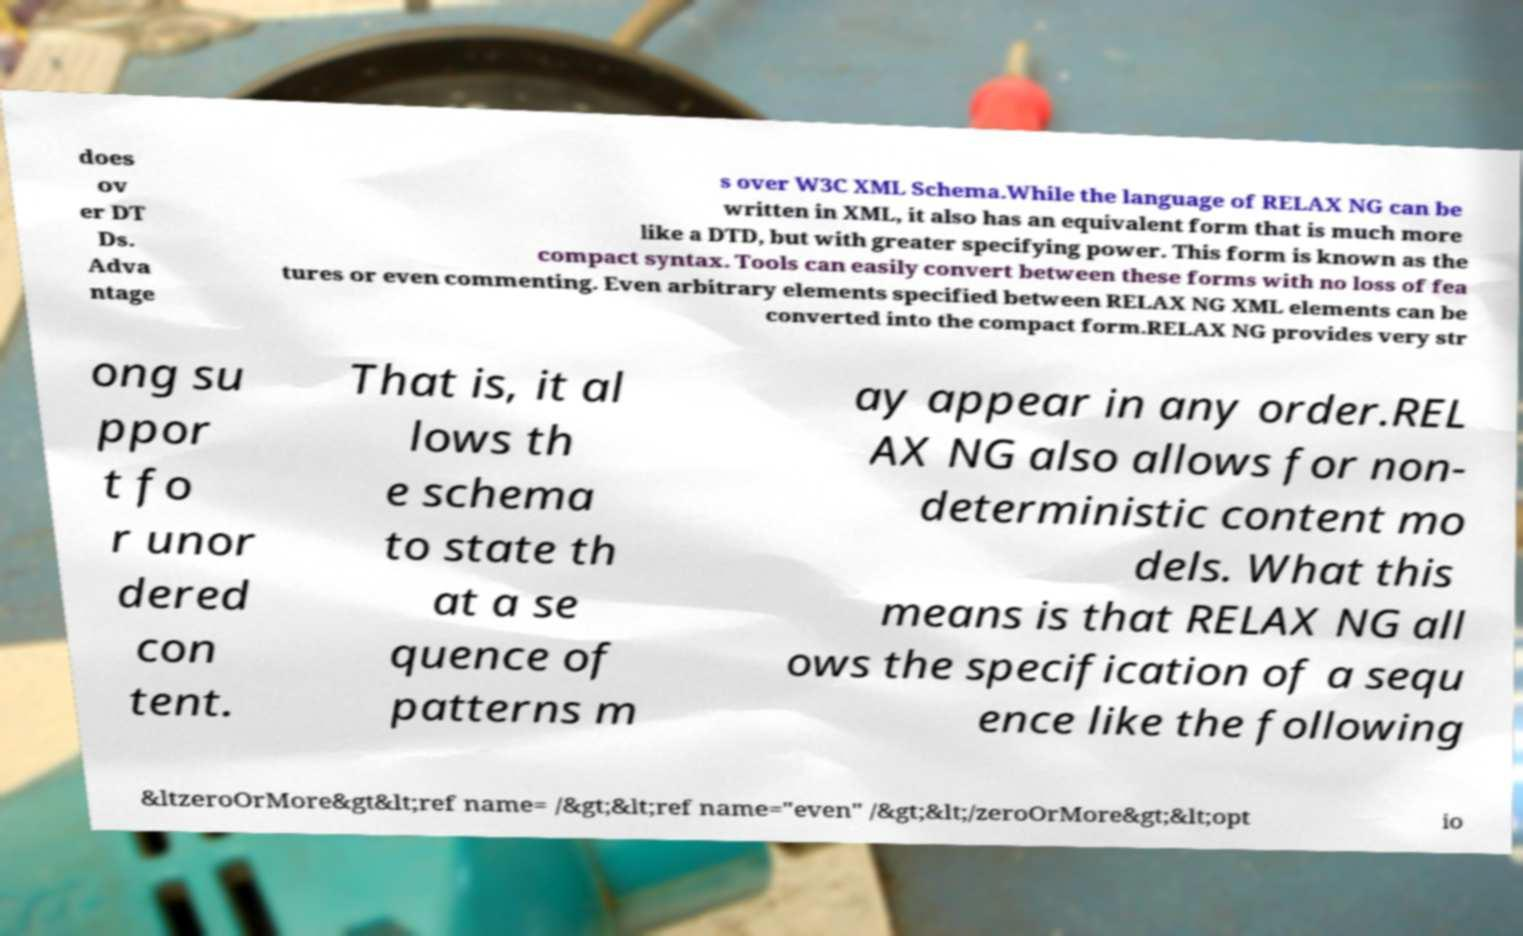Please identify and transcribe the text found in this image. does ov er DT Ds. Adva ntage s over W3C XML Schema.While the language of RELAX NG can be written in XML, it also has an equivalent form that is much more like a DTD, but with greater specifying power. This form is known as the compact syntax. Tools can easily convert between these forms with no loss of fea tures or even commenting. Even arbitrary elements specified between RELAX NG XML elements can be converted into the compact form.RELAX NG provides very str ong su ppor t fo r unor dered con tent. That is, it al lows th e schema to state th at a se quence of patterns m ay appear in any order.REL AX NG also allows for non- deterministic content mo dels. What this means is that RELAX NG all ows the specification of a sequ ence like the following &ltzeroOrMore&gt&lt;ref name= /&gt;&lt;ref name="even" /&gt;&lt;/zeroOrMore&gt;&lt;opt io 